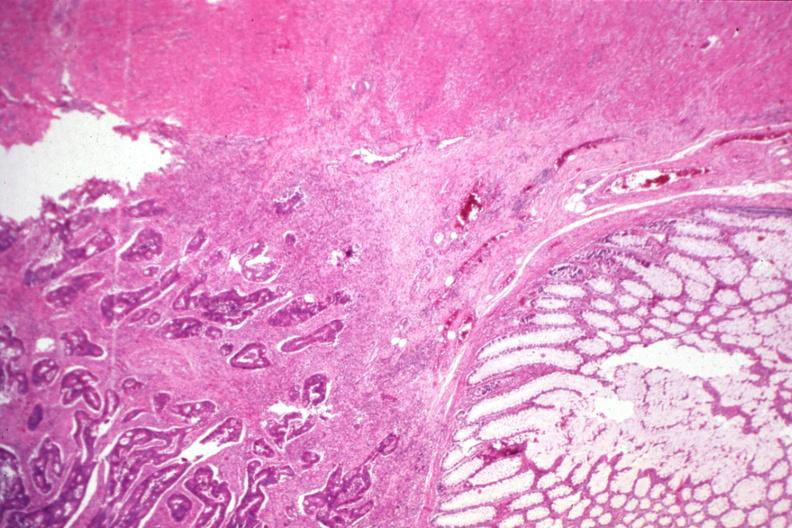s omentum present?
Answer the question using a single word or phrase. No 